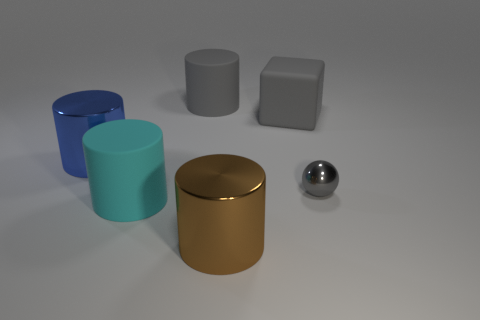What materials appear to be depicted in this image? The objects seem to be rendered with a metallic sheen, suggesting they might be made of polished metal or a material with similar reflective properties. The surface on which they are sitting appears matte, possibly simulating a dull plastic or painted wood. 